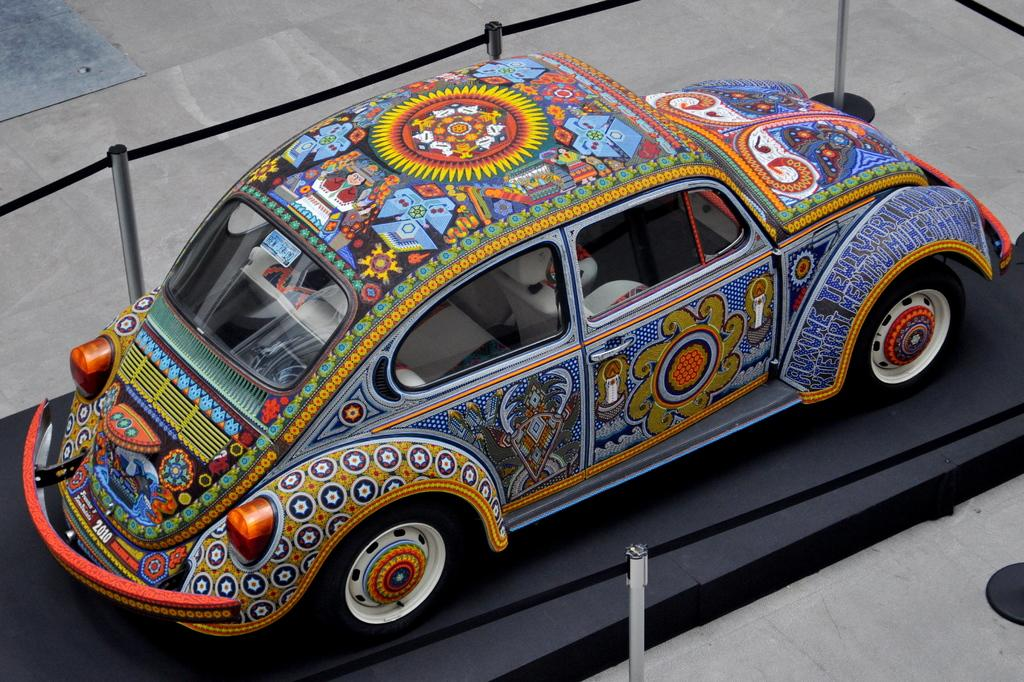What is the main subject of the image? The main subject of the image is a car. Where is the car located in the image? The car is on a platform in the image. What else can be seen on the floor in the image? There are poles on the floor in the image. How many creatures are flying around the car in the image? There are no creatures flying around the car in the image. What is the amount of water visible in the image? There is no water visible in the image. 